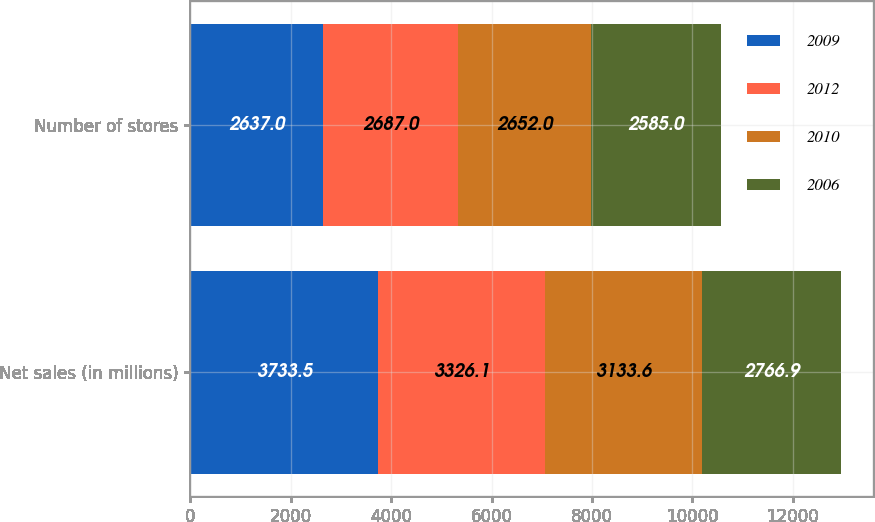Convert chart to OTSL. <chart><loc_0><loc_0><loc_500><loc_500><stacked_bar_chart><ecel><fcel>Net sales (in millions)<fcel>Number of stores<nl><fcel>2009<fcel>3733.5<fcel>2637<nl><fcel>2012<fcel>3326.1<fcel>2687<nl><fcel>2010<fcel>3133.6<fcel>2652<nl><fcel>2006<fcel>2766.9<fcel>2585<nl></chart> 